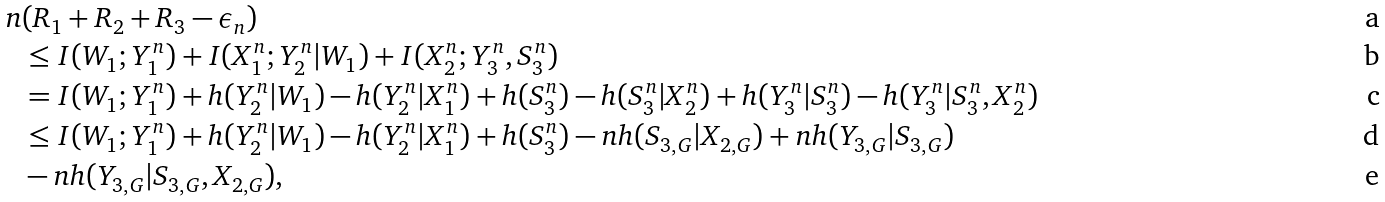Convert formula to latex. <formula><loc_0><loc_0><loc_500><loc_500>n & ( R _ { 1 } + R _ { 2 } + R _ { 3 } - \epsilon _ { n } ) \\ & \leq I ( W _ { 1 } ; Y _ { 1 } ^ { n } ) + I ( X _ { 1 } ^ { n } ; Y _ { 2 } ^ { n } | W _ { 1 } ) + I ( X _ { 2 } ^ { n } ; Y _ { 3 } ^ { n } , S _ { 3 } ^ { n } ) \\ & = I ( W _ { 1 } ; Y _ { 1 } ^ { n } ) + h ( Y _ { 2 } ^ { n } | W _ { 1 } ) - h ( Y _ { 2 } ^ { n } | X _ { 1 } ^ { n } ) + h ( S _ { 3 } ^ { n } ) - h ( S _ { 3 } ^ { n } | X _ { 2 } ^ { n } ) + h ( Y _ { 3 } ^ { n } | S _ { 3 } ^ { n } ) - h ( Y _ { 3 } ^ { n } | S _ { 3 } ^ { n } , X _ { 2 } ^ { n } ) \\ & \leq I ( W _ { 1 } ; Y _ { 1 } ^ { n } ) + h ( Y _ { 2 } ^ { n } | W _ { 1 } ) - h ( Y _ { 2 } ^ { n } | X _ { 1 } ^ { n } ) + h ( S _ { 3 } ^ { n } ) - n h ( S _ { 3 , G } | X _ { 2 , G } ) + n h ( Y _ { 3 , G } | S _ { 3 , G } ) \\ & - n h ( Y _ { 3 , G } | S _ { 3 , G } , X _ { 2 , G } ) ,</formula> 